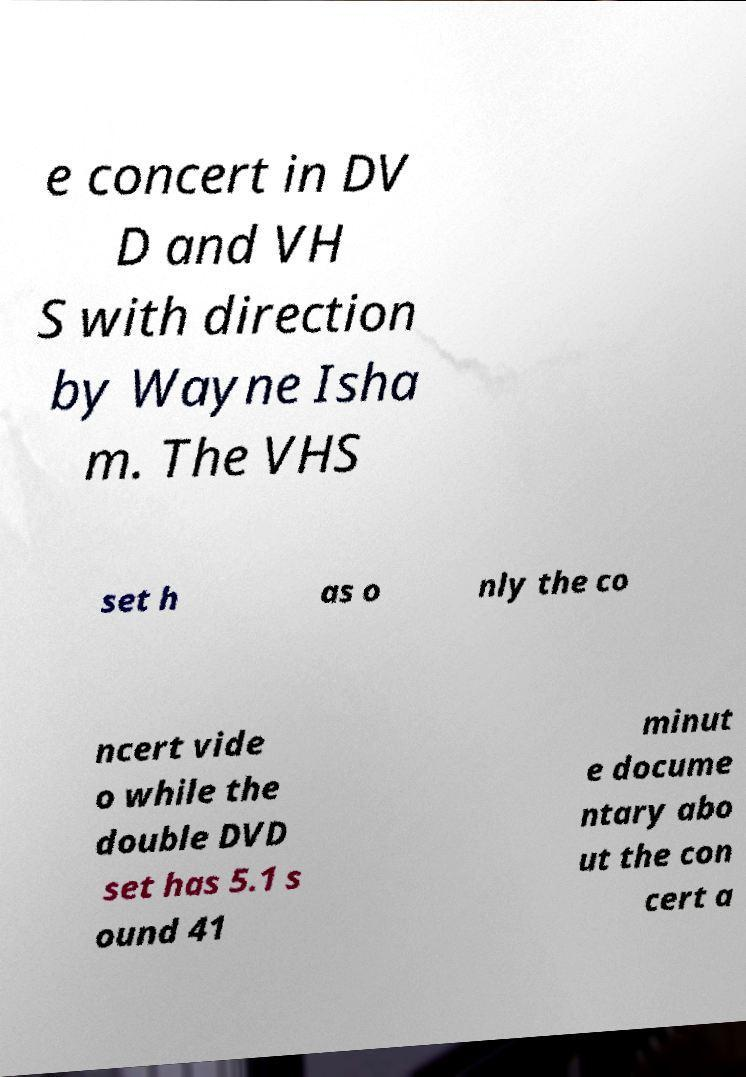Could you assist in decoding the text presented in this image and type it out clearly? e concert in DV D and VH S with direction by Wayne Isha m. The VHS set h as o nly the co ncert vide o while the double DVD set has 5.1 s ound 41 minut e docume ntary abo ut the con cert a 